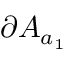<formula> <loc_0><loc_0><loc_500><loc_500>\partial A _ { a _ { 1 } }</formula> 